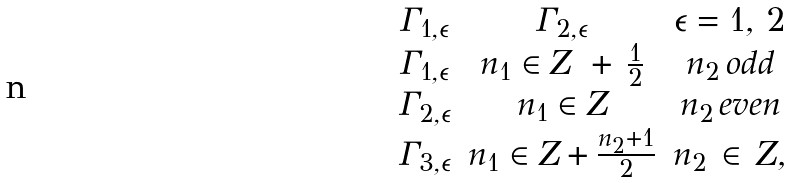<formula> <loc_0><loc_0><loc_500><loc_500>\begin{array} { c c c c } \Gamma _ { 1 , \epsilon } & \Gamma _ { 2 , \epsilon } & \epsilon = 1 , \, 2 \\ \Gamma _ { 1 , \epsilon } & n _ { 1 } \in Z \ + \, \frac { 1 } { 2 } & n _ { 2 } \, o d d \\ \Gamma _ { 2 , \epsilon } & n _ { 1 } \in Z & n _ { 2 } \, e v e n \\ \Gamma _ { 3 , \epsilon } & n _ { 1 } \in Z + \frac { n _ { 2 } + 1 } { 2 } & n _ { 2 } \, \in \, Z , \end{array}</formula> 